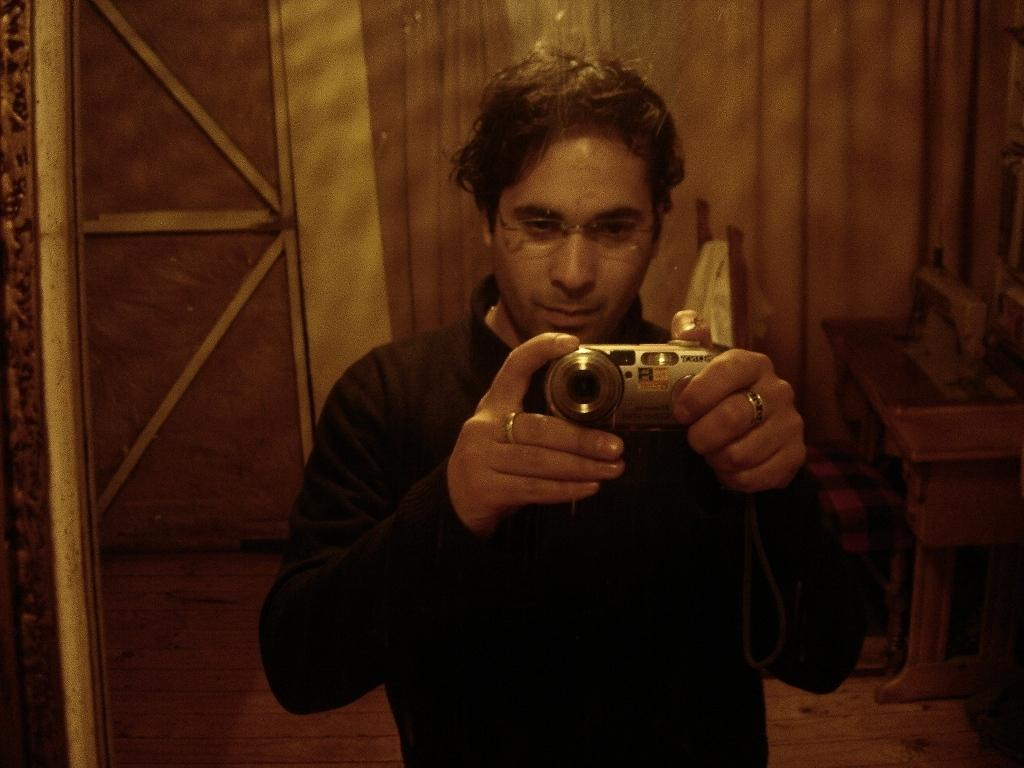What is the main subject of the image? There is a man in the image. What is the man wearing? The man is wearing a black shirt. What is the man holding in the image? The man is holding a camera. Can you describe any accessories the man is wearing? The man has a ring on both hands. What can be seen in the background of the image? There is a wooden wall in the background of the image. Is the man experiencing pain while jumping in the image? There is no indication of the man jumping or experiencing pain in the image. 